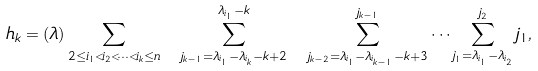Convert formula to latex. <formula><loc_0><loc_0><loc_500><loc_500>h _ { k } = ( \lambda ) \sum _ { 2 \leq i _ { 1 } < i _ { 2 } < \dots < i _ { k } \leq n } \ \sum _ { j _ { k - 1 } = \lambda _ { i _ { 1 } } - \lambda _ { i _ { k } } - k + 2 } ^ { \lambda _ { i _ { 1 } } - k } \ \sum _ { j _ { k - 2 } = \lambda _ { i _ { 1 } } - \lambda _ { i _ { k - 1 } } - k + 3 } ^ { j _ { k - 1 } } \dots \sum _ { j _ { 1 } = \lambda _ { i _ { 1 } } - \lambda _ { i _ { 2 } } } ^ { j _ { 2 } } j _ { 1 } ,</formula> 